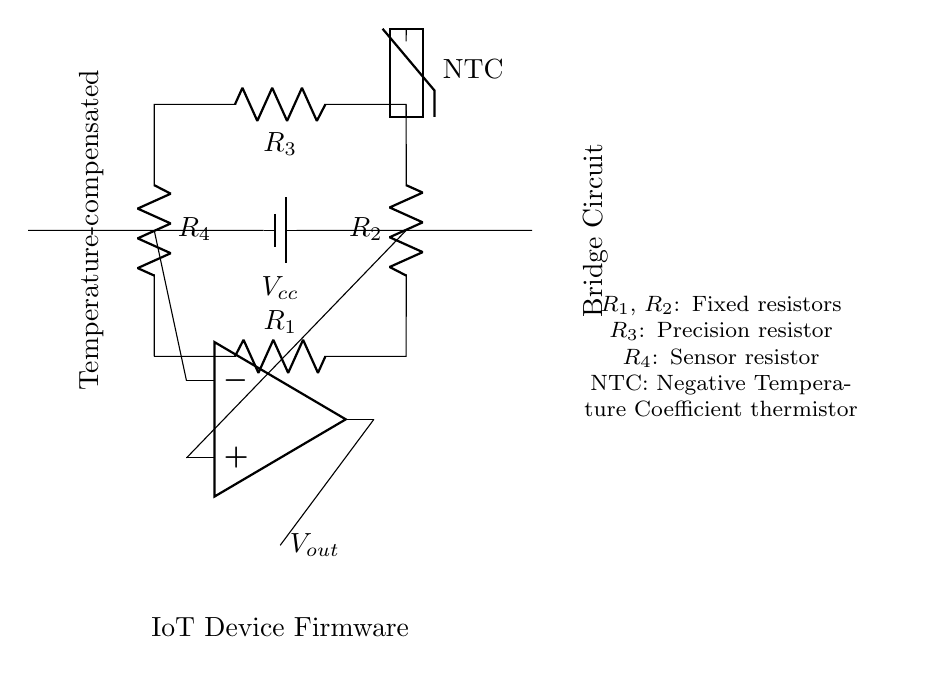What are the components of the bridge circuit? The components visible in the circuit include four resistors (R1, R2, R3, R4), a thermistor, a voltage source (Vcc), and an operational amplifier.
Answer: four resistors, a thermistor, a voltage source, an operational amplifier What type of thermistor is used in this circuit? The circuit specifies an NTC (Negative Temperature Coefficient) thermistor, indicating that its resistance decreases as the temperature increases.
Answer: NTC How many resistors are in the bridge circuit? The bridge circuit features four resistors, namely R1, R2, R3, and R4, arranged in a loop to form the bridge configuration.
Answer: four What is the output of the operational amplifier? The output voltage of the operational amplifier is denoted as Vout, which is the resultant voltage influenced by the sensor readings from the thermistor and other resistors in the circuit.
Answer: Vout What is the purpose of the precision resistor R3? R3 is designated as a precision resistor, which is crucial for maintaining a balance in the bridge circuit, thereby providing accurate sensor readings and temperature compensation.
Answer: maintain balance How does the bridge circuit help in temperature compensation? The bridge circuit achieves temperature compensation by utilizing a thermistor with R4 and a set of fixed resistors, allowing the circuit to measure changes in temperature accurately through varying resistance.
Answer: varying resistance What does Vcc represent in the circuit? Vcc represents the voltage source that powers the entire circuit and is essential for supplying the necessary current for the sensor and amplifier operations.
Answer: voltage source 